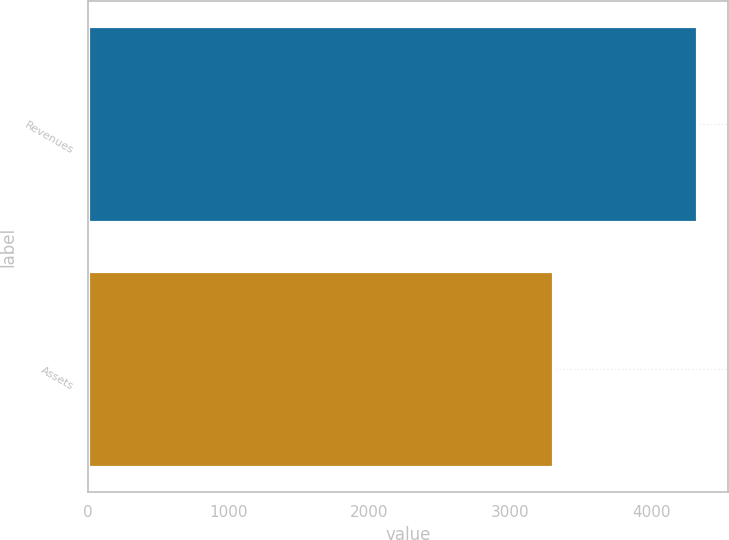<chart> <loc_0><loc_0><loc_500><loc_500><bar_chart><fcel>Revenues<fcel>Assets<nl><fcel>4329.9<fcel>3304.7<nl></chart> 